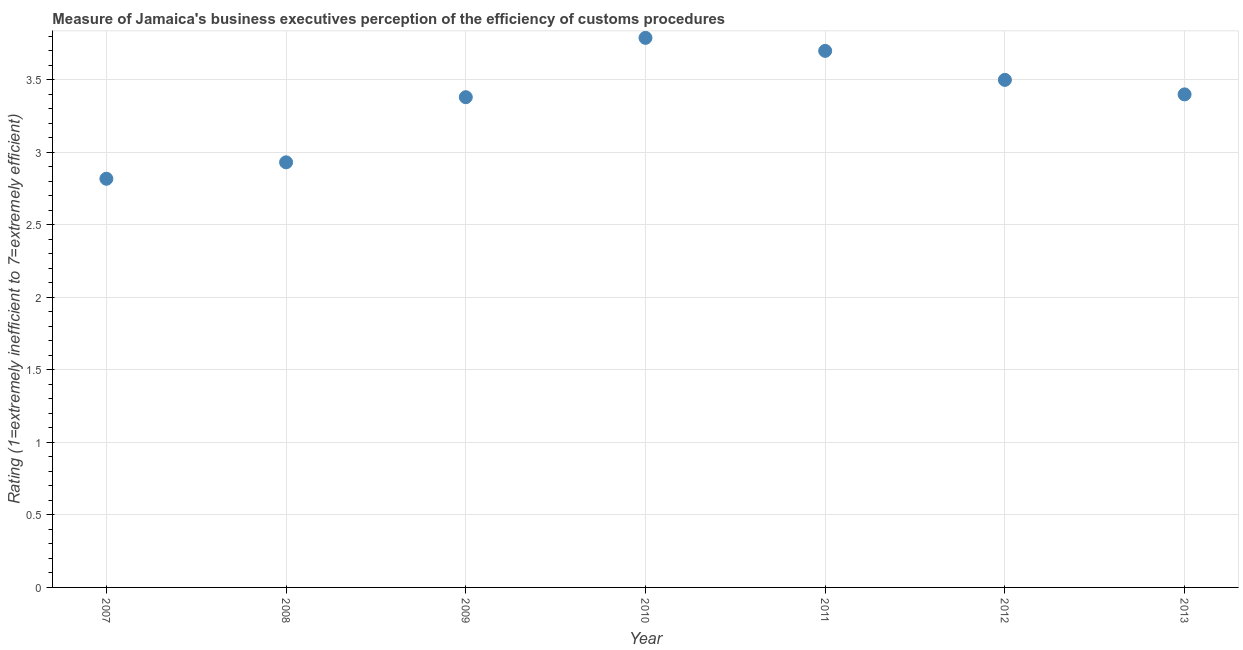Across all years, what is the maximum rating measuring burden of customs procedure?
Ensure brevity in your answer.  3.79. Across all years, what is the minimum rating measuring burden of customs procedure?
Keep it short and to the point. 2.82. In which year was the rating measuring burden of customs procedure maximum?
Offer a terse response. 2010. What is the sum of the rating measuring burden of customs procedure?
Your answer should be very brief. 23.52. What is the difference between the rating measuring burden of customs procedure in 2011 and 2012?
Your answer should be compact. 0.2. What is the average rating measuring burden of customs procedure per year?
Offer a very short reply. 3.36. What is the median rating measuring burden of customs procedure?
Offer a terse response. 3.4. What is the ratio of the rating measuring burden of customs procedure in 2008 to that in 2011?
Make the answer very short. 0.79. What is the difference between the highest and the second highest rating measuring burden of customs procedure?
Offer a terse response. 0.09. Is the sum of the rating measuring burden of customs procedure in 2009 and 2013 greater than the maximum rating measuring burden of customs procedure across all years?
Offer a very short reply. Yes. What is the difference between the highest and the lowest rating measuring burden of customs procedure?
Ensure brevity in your answer.  0.97. Does the rating measuring burden of customs procedure monotonically increase over the years?
Keep it short and to the point. No. How many dotlines are there?
Provide a succinct answer. 1. What is the difference between two consecutive major ticks on the Y-axis?
Keep it short and to the point. 0.5. Does the graph contain grids?
Keep it short and to the point. Yes. What is the title of the graph?
Ensure brevity in your answer.  Measure of Jamaica's business executives perception of the efficiency of customs procedures. What is the label or title of the X-axis?
Keep it short and to the point. Year. What is the label or title of the Y-axis?
Keep it short and to the point. Rating (1=extremely inefficient to 7=extremely efficient). What is the Rating (1=extremely inefficient to 7=extremely efficient) in 2007?
Your answer should be very brief. 2.82. What is the Rating (1=extremely inefficient to 7=extremely efficient) in 2008?
Keep it short and to the point. 2.93. What is the Rating (1=extremely inefficient to 7=extremely efficient) in 2009?
Your response must be concise. 3.38. What is the Rating (1=extremely inefficient to 7=extremely efficient) in 2010?
Make the answer very short. 3.79. What is the Rating (1=extremely inefficient to 7=extremely efficient) in 2011?
Provide a succinct answer. 3.7. What is the Rating (1=extremely inefficient to 7=extremely efficient) in 2012?
Keep it short and to the point. 3.5. What is the Rating (1=extremely inefficient to 7=extremely efficient) in 2013?
Your response must be concise. 3.4. What is the difference between the Rating (1=extremely inefficient to 7=extremely efficient) in 2007 and 2008?
Ensure brevity in your answer.  -0.11. What is the difference between the Rating (1=extremely inefficient to 7=extremely efficient) in 2007 and 2009?
Make the answer very short. -0.56. What is the difference between the Rating (1=extremely inefficient to 7=extremely efficient) in 2007 and 2010?
Your answer should be very brief. -0.97. What is the difference between the Rating (1=extremely inefficient to 7=extremely efficient) in 2007 and 2011?
Give a very brief answer. -0.88. What is the difference between the Rating (1=extremely inefficient to 7=extremely efficient) in 2007 and 2012?
Offer a terse response. -0.68. What is the difference between the Rating (1=extremely inefficient to 7=extremely efficient) in 2007 and 2013?
Your response must be concise. -0.58. What is the difference between the Rating (1=extremely inefficient to 7=extremely efficient) in 2008 and 2009?
Keep it short and to the point. -0.45. What is the difference between the Rating (1=extremely inefficient to 7=extremely efficient) in 2008 and 2010?
Your answer should be compact. -0.86. What is the difference between the Rating (1=extremely inefficient to 7=extremely efficient) in 2008 and 2011?
Ensure brevity in your answer.  -0.77. What is the difference between the Rating (1=extremely inefficient to 7=extremely efficient) in 2008 and 2012?
Offer a very short reply. -0.57. What is the difference between the Rating (1=extremely inefficient to 7=extremely efficient) in 2008 and 2013?
Offer a terse response. -0.47. What is the difference between the Rating (1=extremely inefficient to 7=extremely efficient) in 2009 and 2010?
Your response must be concise. -0.41. What is the difference between the Rating (1=extremely inefficient to 7=extremely efficient) in 2009 and 2011?
Ensure brevity in your answer.  -0.32. What is the difference between the Rating (1=extremely inefficient to 7=extremely efficient) in 2009 and 2012?
Your response must be concise. -0.12. What is the difference between the Rating (1=extremely inefficient to 7=extremely efficient) in 2009 and 2013?
Give a very brief answer. -0.02. What is the difference between the Rating (1=extremely inefficient to 7=extremely efficient) in 2010 and 2011?
Provide a short and direct response. 0.09. What is the difference between the Rating (1=extremely inefficient to 7=extremely efficient) in 2010 and 2012?
Offer a terse response. 0.29. What is the difference between the Rating (1=extremely inefficient to 7=extremely efficient) in 2010 and 2013?
Offer a terse response. 0.39. What is the difference between the Rating (1=extremely inefficient to 7=extremely efficient) in 2011 and 2012?
Give a very brief answer. 0.2. What is the difference between the Rating (1=extremely inefficient to 7=extremely efficient) in 2011 and 2013?
Ensure brevity in your answer.  0.3. What is the ratio of the Rating (1=extremely inefficient to 7=extremely efficient) in 2007 to that in 2008?
Your response must be concise. 0.96. What is the ratio of the Rating (1=extremely inefficient to 7=extremely efficient) in 2007 to that in 2009?
Your answer should be very brief. 0.83. What is the ratio of the Rating (1=extremely inefficient to 7=extremely efficient) in 2007 to that in 2010?
Keep it short and to the point. 0.74. What is the ratio of the Rating (1=extremely inefficient to 7=extremely efficient) in 2007 to that in 2011?
Your answer should be very brief. 0.76. What is the ratio of the Rating (1=extremely inefficient to 7=extremely efficient) in 2007 to that in 2012?
Keep it short and to the point. 0.81. What is the ratio of the Rating (1=extremely inefficient to 7=extremely efficient) in 2007 to that in 2013?
Give a very brief answer. 0.83. What is the ratio of the Rating (1=extremely inefficient to 7=extremely efficient) in 2008 to that in 2009?
Offer a very short reply. 0.87. What is the ratio of the Rating (1=extremely inefficient to 7=extremely efficient) in 2008 to that in 2010?
Provide a succinct answer. 0.77. What is the ratio of the Rating (1=extremely inefficient to 7=extremely efficient) in 2008 to that in 2011?
Your answer should be very brief. 0.79. What is the ratio of the Rating (1=extremely inefficient to 7=extremely efficient) in 2008 to that in 2012?
Provide a short and direct response. 0.84. What is the ratio of the Rating (1=extremely inefficient to 7=extremely efficient) in 2008 to that in 2013?
Offer a terse response. 0.86. What is the ratio of the Rating (1=extremely inefficient to 7=extremely efficient) in 2009 to that in 2010?
Make the answer very short. 0.89. What is the ratio of the Rating (1=extremely inefficient to 7=extremely efficient) in 2009 to that in 2011?
Offer a terse response. 0.91. What is the ratio of the Rating (1=extremely inefficient to 7=extremely efficient) in 2009 to that in 2012?
Give a very brief answer. 0.97. What is the ratio of the Rating (1=extremely inefficient to 7=extremely efficient) in 2009 to that in 2013?
Your answer should be very brief. 0.99. What is the ratio of the Rating (1=extremely inefficient to 7=extremely efficient) in 2010 to that in 2011?
Provide a short and direct response. 1.02. What is the ratio of the Rating (1=extremely inefficient to 7=extremely efficient) in 2010 to that in 2012?
Your answer should be very brief. 1.08. What is the ratio of the Rating (1=extremely inefficient to 7=extremely efficient) in 2010 to that in 2013?
Make the answer very short. 1.11. What is the ratio of the Rating (1=extremely inefficient to 7=extremely efficient) in 2011 to that in 2012?
Make the answer very short. 1.06. What is the ratio of the Rating (1=extremely inefficient to 7=extremely efficient) in 2011 to that in 2013?
Give a very brief answer. 1.09. 